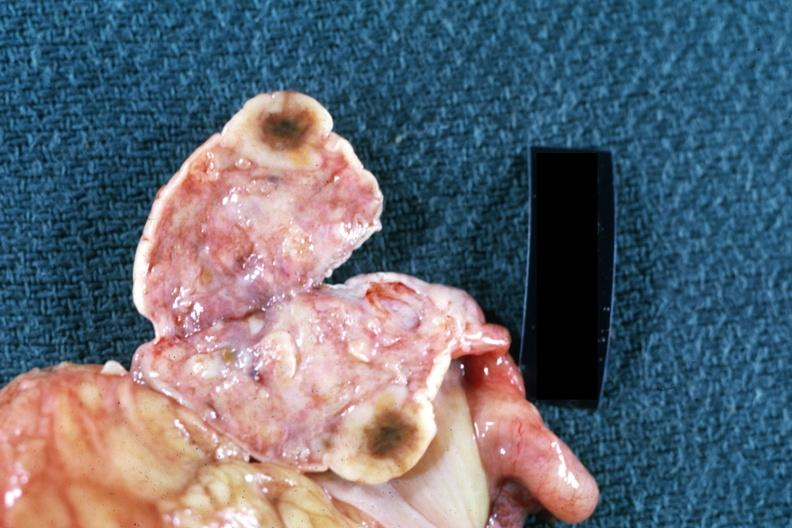where does this belong to?
Answer the question using a single word or phrase. Female reproductive system 